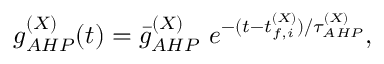Convert formula to latex. <formula><loc_0><loc_0><loc_500><loc_500>g _ { A H P } ^ { ( X ) } ( t ) = \bar { g } _ { A H P } ^ { ( X ) } e ^ { - ( t - t _ { f , i } ^ { ( X ) } ) / \tau _ { A H P } ^ { ( X ) } } ,</formula> 